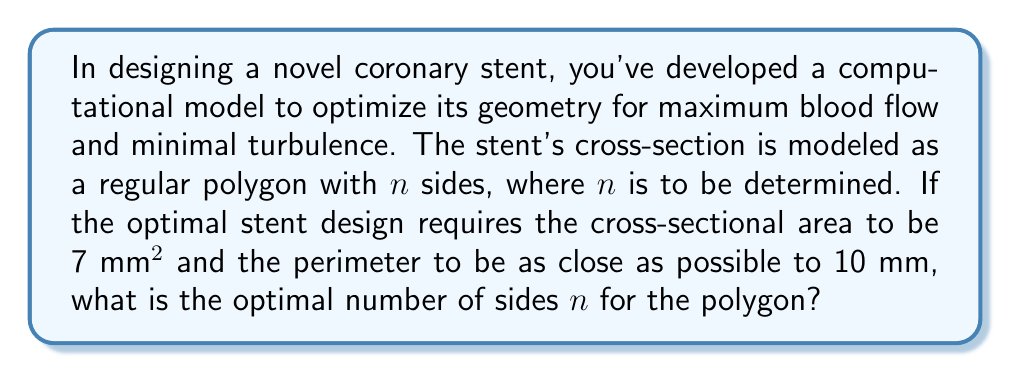Teach me how to tackle this problem. Let's approach this step-by-step:

1) For a regular polygon with $n$ sides, side length $s$, and apothem $a$, we have:
   Area: $A = \frac{1}{2}n s a$
   Perimeter: $P = n s$

2) We're given that $A = 7$ mm² and we want $P$ to be as close as possible to 10 mm.

3) For a regular polygon, we can express $a$ in terms of $s$ and $n$:
   $a = \frac{s}{2 \tan(\frac{\pi}{n})}$

4) Substituting this into the area formula:
   $7 = \frac{1}{2}n s \frac{s}{2 \tan(\frac{\pi}{n})}$
   $7 = \frac{n s^2}{4 \tan(\frac{\pi}{n})}$

5) Solving for $s$:
   $s = \sqrt{\frac{28 \tan(\frac{\pi}{n})}{n}}$

6) Now, we can express the perimeter in terms of $n$:
   $P = n \sqrt{\frac{28 \tan(\frac{\pi}{n})}{n}}$

7) We want to find $n$ that makes $P$ as close to 10 as possible. This is equivalent to minimizing $|P - 10|$.

8) This is a complex optimization problem that doesn't have a simple algebraic solution. We need to use numerical methods.

9) Using a computer algorithm to test integer values of $n$, we find:
   For $n = 8$, $P \approx 9.9408$ mm
   For $n = 9$, $P \approx 10.0511$ mm

10) The perimeter for $n = 8$ is closer to 10 mm than for $n = 9$.

Therefore, the optimal number of sides for the stent's cross-section is 8.
Answer: 8 